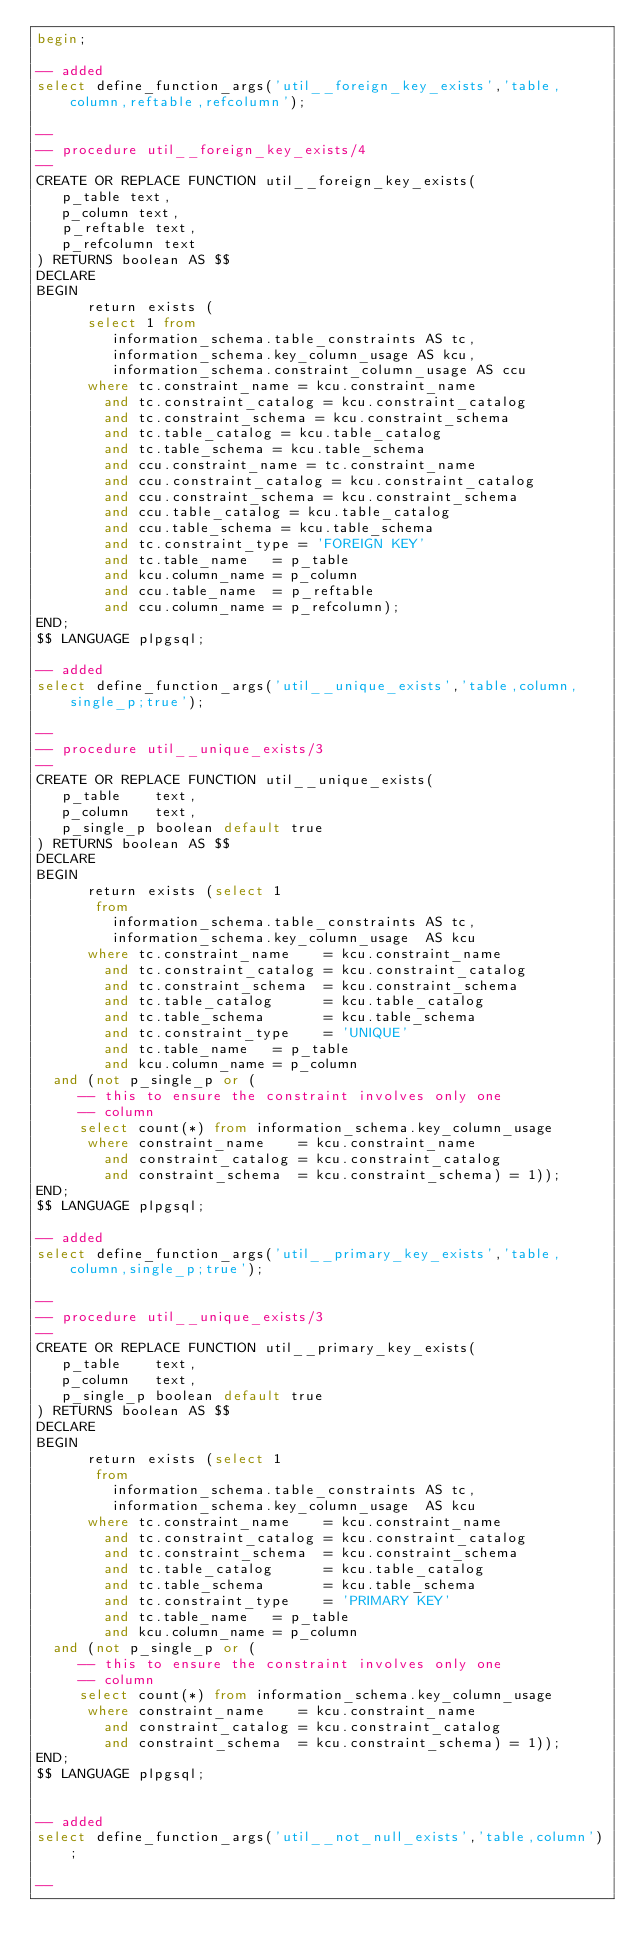Convert code to text. <code><loc_0><loc_0><loc_500><loc_500><_SQL_>begin;

-- added
select define_function_args('util__foreign_key_exists','table,column,reftable,refcolumn');

--
-- procedure util__foreign_key_exists/4
--
CREATE OR REPLACE FUNCTION util__foreign_key_exists(
   p_table text,
   p_column text,
   p_reftable text,
   p_refcolumn text
) RETURNS boolean AS $$
DECLARE
BEGIN
      return exists (
      select 1 from
         information_schema.table_constraints AS tc,
         information_schema.key_column_usage AS kcu,
         information_schema.constraint_column_usage AS ccu
      where tc.constraint_name = kcu.constraint_name
        and tc.constraint_catalog = kcu.constraint_catalog
        and tc.constraint_schema = kcu.constraint_schema
        and tc.table_catalog = kcu.table_catalog
        and tc.table_schema = kcu.table_schema
        and ccu.constraint_name = tc.constraint_name
        and ccu.constraint_catalog = kcu.constraint_catalog
        and ccu.constraint_schema = kcu.constraint_schema
        and ccu.table_catalog = kcu.table_catalog
        and ccu.table_schema = kcu.table_schema
        and tc.constraint_type = 'FOREIGN KEY'
        and tc.table_name   = p_table
        and kcu.column_name = p_column
        and ccu.table_name  = p_reftable
        and ccu.column_name = p_refcolumn);
END;
$$ LANGUAGE plpgsql;

-- added
select define_function_args('util__unique_exists','table,column,single_p;true');

--
-- procedure util__unique_exists/3
--
CREATE OR REPLACE FUNCTION util__unique_exists(
   p_table    text,
   p_column   text,
   p_single_p boolean default true
) RETURNS boolean AS $$
DECLARE
BEGIN
      return exists (select 1
       from
         information_schema.table_constraints AS tc,
         information_schema.key_column_usage  AS kcu
      where tc.constraint_name    = kcu.constraint_name
        and tc.constraint_catalog = kcu.constraint_catalog
        and tc.constraint_schema  = kcu.constraint_schema
        and tc.table_catalog      = kcu.table_catalog
        and tc.table_schema       = kcu.table_schema
        and tc.constraint_type    = 'UNIQUE'
        and tc.table_name   = p_table
        and kcu.column_name = p_column
	and (not p_single_p or (
	   -- this to ensure the constraint involves only one
	   -- column
	   select count(*) from information_schema.key_column_usage
	    where constraint_name    = kcu.constraint_name
	      and constraint_catalog = kcu.constraint_catalog
	      and constraint_schema  = kcu.constraint_schema) = 1));
END;
$$ LANGUAGE plpgsql;

-- added
select define_function_args('util__primary_key_exists','table,column,single_p;true');

--
-- procedure util__unique_exists/3
--
CREATE OR REPLACE FUNCTION util__primary_key_exists(
   p_table    text,
   p_column   text,
   p_single_p boolean default true
) RETURNS boolean AS $$
DECLARE
BEGIN
      return exists (select 1
       from
         information_schema.table_constraints AS tc,
         information_schema.key_column_usage  AS kcu
      where tc.constraint_name    = kcu.constraint_name
        and tc.constraint_catalog = kcu.constraint_catalog
        and tc.constraint_schema  = kcu.constraint_schema
        and tc.table_catalog      = kcu.table_catalog
        and tc.table_schema       = kcu.table_schema
        and tc.constraint_type    = 'PRIMARY KEY'
        and tc.table_name   = p_table
        and kcu.column_name = p_column
	and (not p_single_p or (
	   -- this to ensure the constraint involves only one
	   -- column
	   select count(*) from information_schema.key_column_usage
	    where constraint_name    = kcu.constraint_name
	      and constraint_catalog = kcu.constraint_catalog
	      and constraint_schema  = kcu.constraint_schema) = 1));
END;
$$ LANGUAGE plpgsql;


-- added
select define_function_args('util__not_null_exists','table,column');

--</code> 